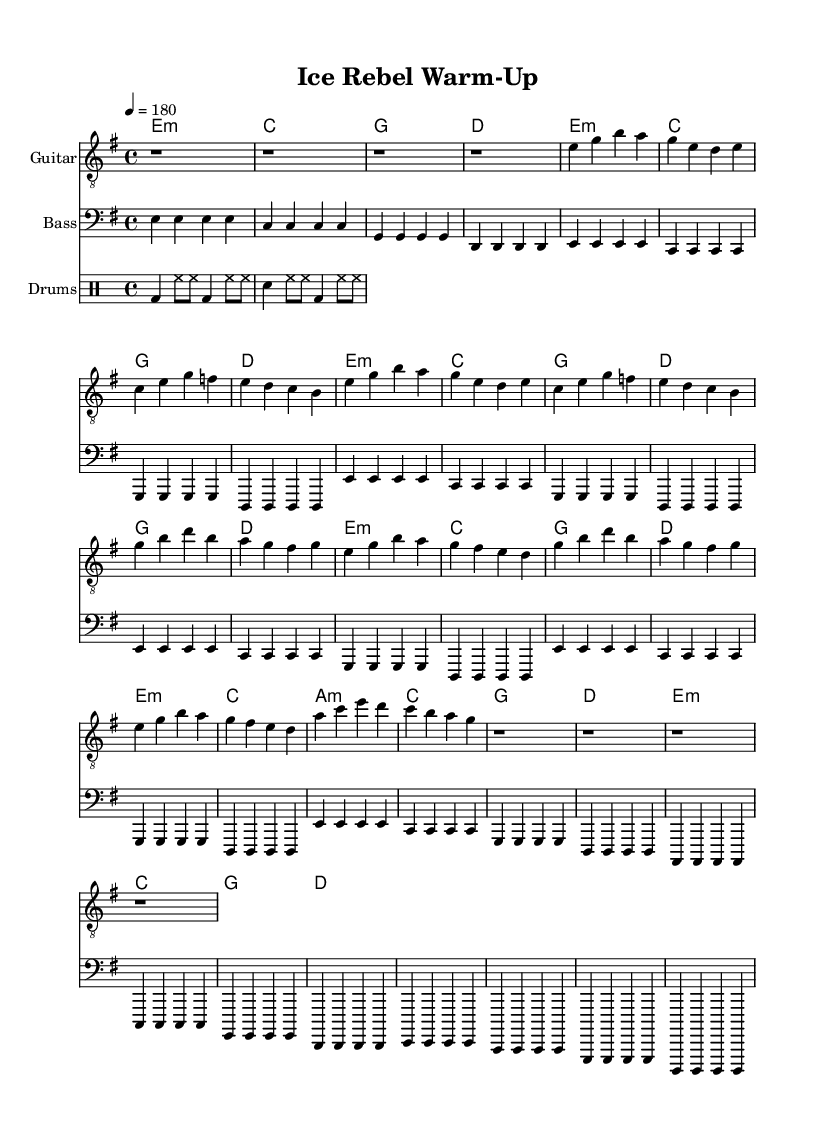What is the key signature of this music? The key signature is E minor, which has one sharp (F#). This is indicated at the beginning of the sheet music with the sharp sign placed on the F line in the staff.
Answer: E minor What is the time signature of this piece? The time signature is 4/4, as shown at the beginning of the score. This indicates that there are four beats in each measure and a quarter note gets one beat.
Answer: 4/4 What is the tempo marking for this track? The tempo marking is 180 beats per minute, indicated at the beginning of the score. This means the piece is played very fast, typical for high-energy punk music.
Answer: 180 How many measures are there in the verse section? The verse section consists of 8 measures. By counting each group in the verse, we see there are two repeated sections of 4 measures each.
Answer: 8 Which chord is played in the first measure? The first measure features the E minor chord, as indicated in the chord line that starts with E minor.
Answer: E minor What is the feel of the rhythm in the drums section? The rhythm is consistent with a strong backbeat provided by the bass drum and snare, typical for punk music that drives forward energy. This can be deduced from the pattern of beats in the drums section.
Answer: Strong backbeat What key elements define this as a punk track? The track features fast tempo, distorted guitar riffs, and driving bass lines, which are signature elements of punk music, evident from the style and structure of the score.
Answer: Fast tempo, harsh guitar 